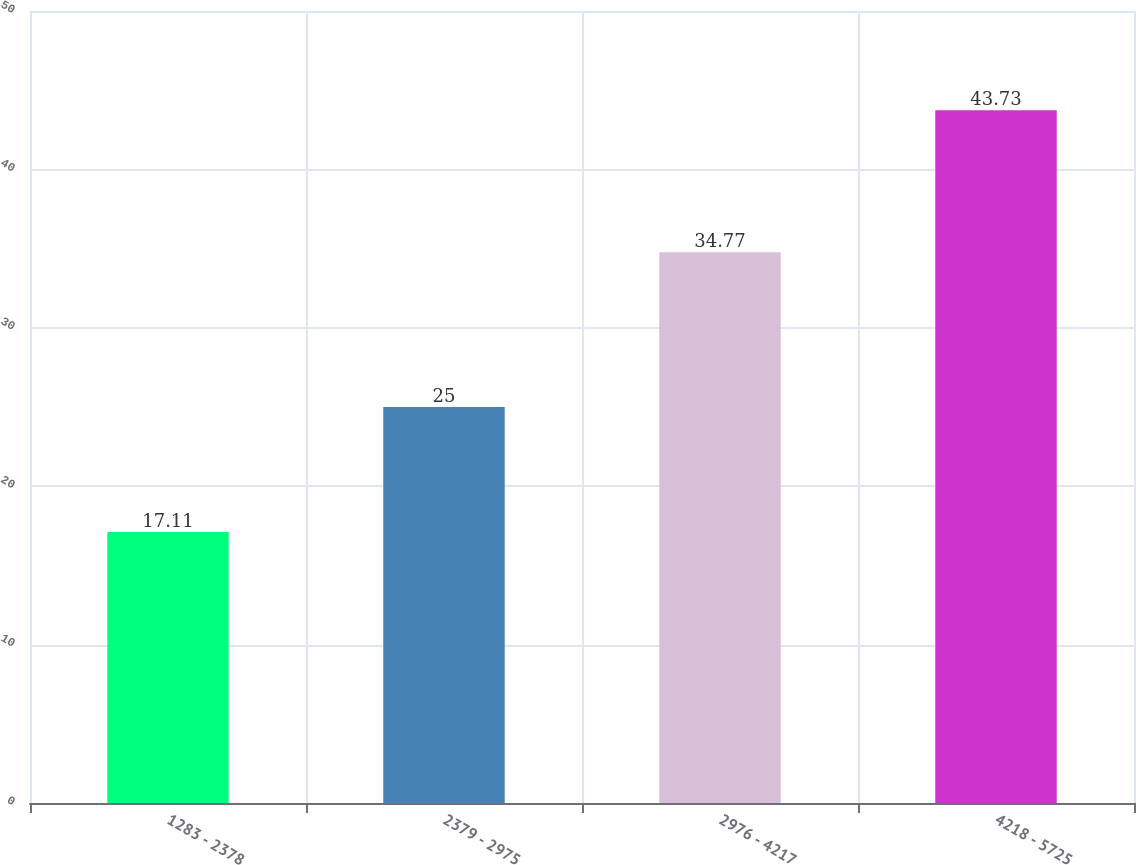Convert chart to OTSL. <chart><loc_0><loc_0><loc_500><loc_500><bar_chart><fcel>1283 - 2378<fcel>2379 - 2975<fcel>2976 - 4217<fcel>4218 - 5725<nl><fcel>17.11<fcel>25<fcel>34.77<fcel>43.73<nl></chart> 